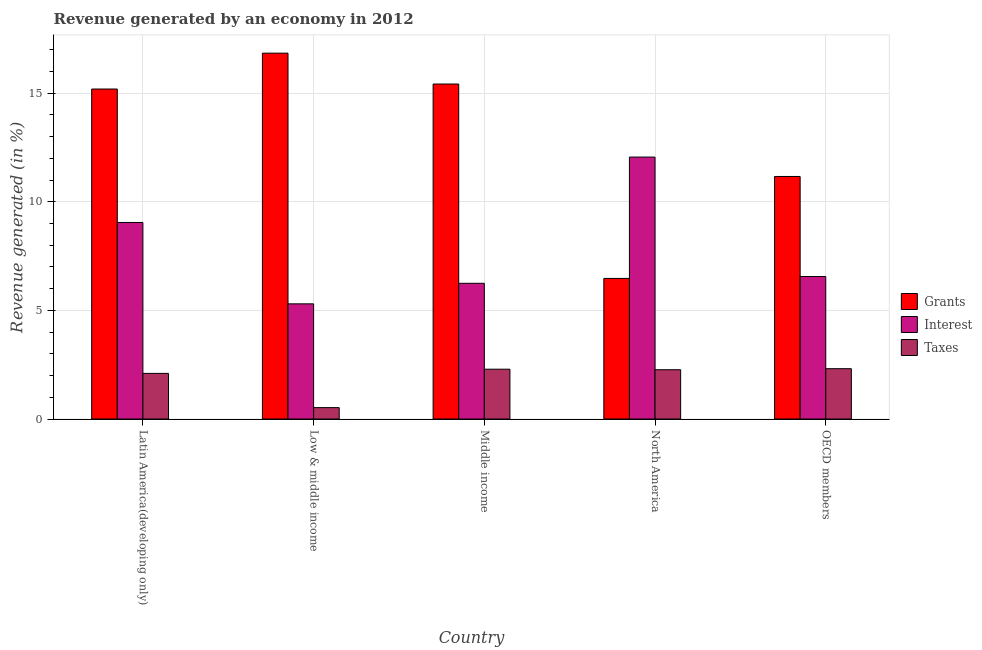How many groups of bars are there?
Give a very brief answer. 5. Are the number of bars per tick equal to the number of legend labels?
Offer a terse response. Yes. Are the number of bars on each tick of the X-axis equal?
Offer a terse response. Yes. In how many cases, is the number of bars for a given country not equal to the number of legend labels?
Your answer should be compact. 0. What is the percentage of revenue generated by taxes in Low & middle income?
Give a very brief answer. 0.52. Across all countries, what is the maximum percentage of revenue generated by grants?
Offer a very short reply. 16.84. Across all countries, what is the minimum percentage of revenue generated by interest?
Your response must be concise. 5.3. In which country was the percentage of revenue generated by taxes maximum?
Provide a short and direct response. OECD members. In which country was the percentage of revenue generated by taxes minimum?
Your response must be concise. Low & middle income. What is the total percentage of revenue generated by interest in the graph?
Provide a succinct answer. 39.21. What is the difference between the percentage of revenue generated by grants in North America and that in OECD members?
Give a very brief answer. -4.69. What is the difference between the percentage of revenue generated by grants in OECD members and the percentage of revenue generated by taxes in Middle income?
Ensure brevity in your answer.  8.87. What is the average percentage of revenue generated by taxes per country?
Offer a very short reply. 1.9. What is the difference between the percentage of revenue generated by interest and percentage of revenue generated by taxes in North America?
Your response must be concise. 9.79. What is the ratio of the percentage of revenue generated by taxes in Middle income to that in North America?
Provide a short and direct response. 1.01. Is the difference between the percentage of revenue generated by taxes in Middle income and North America greater than the difference between the percentage of revenue generated by grants in Middle income and North America?
Provide a succinct answer. No. What is the difference between the highest and the second highest percentage of revenue generated by interest?
Make the answer very short. 3.01. What is the difference between the highest and the lowest percentage of revenue generated by grants?
Your answer should be compact. 10.37. Is the sum of the percentage of revenue generated by taxes in Low & middle income and Middle income greater than the maximum percentage of revenue generated by interest across all countries?
Your response must be concise. No. What does the 2nd bar from the left in OECD members represents?
Make the answer very short. Interest. What does the 3rd bar from the right in Latin America(developing only) represents?
Give a very brief answer. Grants. How many bars are there?
Provide a succinct answer. 15. Are all the bars in the graph horizontal?
Offer a terse response. No. What is the difference between two consecutive major ticks on the Y-axis?
Your answer should be compact. 5. Are the values on the major ticks of Y-axis written in scientific E-notation?
Your answer should be compact. No. Where does the legend appear in the graph?
Offer a very short reply. Center right. What is the title of the graph?
Provide a succinct answer. Revenue generated by an economy in 2012. Does "Domestic economy" appear as one of the legend labels in the graph?
Your response must be concise. No. What is the label or title of the Y-axis?
Your answer should be very brief. Revenue generated (in %). What is the Revenue generated (in %) of Grants in Latin America(developing only)?
Provide a short and direct response. 15.19. What is the Revenue generated (in %) of Interest in Latin America(developing only)?
Offer a terse response. 9.05. What is the Revenue generated (in %) of Taxes in Latin America(developing only)?
Make the answer very short. 2.1. What is the Revenue generated (in %) in Grants in Low & middle income?
Your response must be concise. 16.84. What is the Revenue generated (in %) of Interest in Low & middle income?
Provide a succinct answer. 5.3. What is the Revenue generated (in %) of Taxes in Low & middle income?
Give a very brief answer. 0.52. What is the Revenue generated (in %) of Grants in Middle income?
Provide a short and direct response. 15.42. What is the Revenue generated (in %) of Interest in Middle income?
Provide a short and direct response. 6.25. What is the Revenue generated (in %) of Taxes in Middle income?
Ensure brevity in your answer.  2.29. What is the Revenue generated (in %) of Grants in North America?
Offer a terse response. 6.47. What is the Revenue generated (in %) in Interest in North America?
Ensure brevity in your answer.  12.06. What is the Revenue generated (in %) in Taxes in North America?
Offer a terse response. 2.27. What is the Revenue generated (in %) of Grants in OECD members?
Your answer should be very brief. 11.16. What is the Revenue generated (in %) in Interest in OECD members?
Your answer should be compact. 6.56. What is the Revenue generated (in %) of Taxes in OECD members?
Your answer should be very brief. 2.32. Across all countries, what is the maximum Revenue generated (in %) in Grants?
Provide a short and direct response. 16.84. Across all countries, what is the maximum Revenue generated (in %) in Interest?
Your answer should be compact. 12.06. Across all countries, what is the maximum Revenue generated (in %) of Taxes?
Keep it short and to the point. 2.32. Across all countries, what is the minimum Revenue generated (in %) of Grants?
Keep it short and to the point. 6.47. Across all countries, what is the minimum Revenue generated (in %) in Interest?
Make the answer very short. 5.3. Across all countries, what is the minimum Revenue generated (in %) of Taxes?
Offer a very short reply. 0.52. What is the total Revenue generated (in %) in Grants in the graph?
Keep it short and to the point. 65.08. What is the total Revenue generated (in %) of Interest in the graph?
Give a very brief answer. 39.21. What is the total Revenue generated (in %) in Taxes in the graph?
Your answer should be compact. 9.5. What is the difference between the Revenue generated (in %) of Grants in Latin America(developing only) and that in Low & middle income?
Your answer should be compact. -1.65. What is the difference between the Revenue generated (in %) in Interest in Latin America(developing only) and that in Low & middle income?
Ensure brevity in your answer.  3.75. What is the difference between the Revenue generated (in %) in Taxes in Latin America(developing only) and that in Low & middle income?
Provide a short and direct response. 1.58. What is the difference between the Revenue generated (in %) in Grants in Latin America(developing only) and that in Middle income?
Give a very brief answer. -0.23. What is the difference between the Revenue generated (in %) of Interest in Latin America(developing only) and that in Middle income?
Provide a short and direct response. 2.8. What is the difference between the Revenue generated (in %) in Taxes in Latin America(developing only) and that in Middle income?
Your answer should be very brief. -0.19. What is the difference between the Revenue generated (in %) of Grants in Latin America(developing only) and that in North America?
Make the answer very short. 8.72. What is the difference between the Revenue generated (in %) of Interest in Latin America(developing only) and that in North America?
Offer a very short reply. -3.01. What is the difference between the Revenue generated (in %) in Taxes in Latin America(developing only) and that in North America?
Provide a short and direct response. -0.17. What is the difference between the Revenue generated (in %) of Grants in Latin America(developing only) and that in OECD members?
Your answer should be compact. 4.03. What is the difference between the Revenue generated (in %) in Interest in Latin America(developing only) and that in OECD members?
Offer a very short reply. 2.49. What is the difference between the Revenue generated (in %) of Taxes in Latin America(developing only) and that in OECD members?
Make the answer very short. -0.22. What is the difference between the Revenue generated (in %) in Grants in Low & middle income and that in Middle income?
Make the answer very short. 1.42. What is the difference between the Revenue generated (in %) in Interest in Low & middle income and that in Middle income?
Provide a short and direct response. -0.95. What is the difference between the Revenue generated (in %) in Taxes in Low & middle income and that in Middle income?
Your answer should be compact. -1.77. What is the difference between the Revenue generated (in %) of Grants in Low & middle income and that in North America?
Offer a very short reply. 10.37. What is the difference between the Revenue generated (in %) of Interest in Low & middle income and that in North America?
Give a very brief answer. -6.76. What is the difference between the Revenue generated (in %) in Taxes in Low & middle income and that in North America?
Provide a short and direct response. -1.74. What is the difference between the Revenue generated (in %) in Grants in Low & middle income and that in OECD members?
Your answer should be compact. 5.68. What is the difference between the Revenue generated (in %) of Interest in Low & middle income and that in OECD members?
Your response must be concise. -1.26. What is the difference between the Revenue generated (in %) of Taxes in Low & middle income and that in OECD members?
Keep it short and to the point. -1.79. What is the difference between the Revenue generated (in %) in Grants in Middle income and that in North America?
Offer a terse response. 8.95. What is the difference between the Revenue generated (in %) in Interest in Middle income and that in North America?
Your response must be concise. -5.81. What is the difference between the Revenue generated (in %) of Taxes in Middle income and that in North America?
Your response must be concise. 0.02. What is the difference between the Revenue generated (in %) in Grants in Middle income and that in OECD members?
Your answer should be very brief. 4.26. What is the difference between the Revenue generated (in %) in Interest in Middle income and that in OECD members?
Provide a short and direct response. -0.31. What is the difference between the Revenue generated (in %) in Taxes in Middle income and that in OECD members?
Your response must be concise. -0.02. What is the difference between the Revenue generated (in %) of Grants in North America and that in OECD members?
Give a very brief answer. -4.69. What is the difference between the Revenue generated (in %) in Interest in North America and that in OECD members?
Your response must be concise. 5.5. What is the difference between the Revenue generated (in %) in Taxes in North America and that in OECD members?
Your answer should be compact. -0.05. What is the difference between the Revenue generated (in %) of Grants in Latin America(developing only) and the Revenue generated (in %) of Interest in Low & middle income?
Provide a short and direct response. 9.89. What is the difference between the Revenue generated (in %) of Grants in Latin America(developing only) and the Revenue generated (in %) of Taxes in Low & middle income?
Provide a succinct answer. 14.66. What is the difference between the Revenue generated (in %) in Interest in Latin America(developing only) and the Revenue generated (in %) in Taxes in Low & middle income?
Your response must be concise. 8.52. What is the difference between the Revenue generated (in %) of Grants in Latin America(developing only) and the Revenue generated (in %) of Interest in Middle income?
Make the answer very short. 8.94. What is the difference between the Revenue generated (in %) in Grants in Latin America(developing only) and the Revenue generated (in %) in Taxes in Middle income?
Provide a short and direct response. 12.9. What is the difference between the Revenue generated (in %) in Interest in Latin America(developing only) and the Revenue generated (in %) in Taxes in Middle income?
Give a very brief answer. 6.75. What is the difference between the Revenue generated (in %) of Grants in Latin America(developing only) and the Revenue generated (in %) of Interest in North America?
Offer a very short reply. 3.13. What is the difference between the Revenue generated (in %) in Grants in Latin America(developing only) and the Revenue generated (in %) in Taxes in North America?
Your answer should be compact. 12.92. What is the difference between the Revenue generated (in %) in Interest in Latin America(developing only) and the Revenue generated (in %) in Taxes in North America?
Provide a succinct answer. 6.78. What is the difference between the Revenue generated (in %) of Grants in Latin America(developing only) and the Revenue generated (in %) of Interest in OECD members?
Offer a terse response. 8.63. What is the difference between the Revenue generated (in %) in Grants in Latin America(developing only) and the Revenue generated (in %) in Taxes in OECD members?
Offer a very short reply. 12.87. What is the difference between the Revenue generated (in %) of Interest in Latin America(developing only) and the Revenue generated (in %) of Taxes in OECD members?
Keep it short and to the point. 6.73. What is the difference between the Revenue generated (in %) of Grants in Low & middle income and the Revenue generated (in %) of Interest in Middle income?
Provide a succinct answer. 10.59. What is the difference between the Revenue generated (in %) in Grants in Low & middle income and the Revenue generated (in %) in Taxes in Middle income?
Give a very brief answer. 14.55. What is the difference between the Revenue generated (in %) in Interest in Low & middle income and the Revenue generated (in %) in Taxes in Middle income?
Your response must be concise. 3.01. What is the difference between the Revenue generated (in %) in Grants in Low & middle income and the Revenue generated (in %) in Interest in North America?
Offer a terse response. 4.78. What is the difference between the Revenue generated (in %) of Grants in Low & middle income and the Revenue generated (in %) of Taxes in North America?
Offer a terse response. 14.57. What is the difference between the Revenue generated (in %) of Interest in Low & middle income and the Revenue generated (in %) of Taxes in North America?
Give a very brief answer. 3.03. What is the difference between the Revenue generated (in %) of Grants in Low & middle income and the Revenue generated (in %) of Interest in OECD members?
Provide a short and direct response. 10.28. What is the difference between the Revenue generated (in %) of Grants in Low & middle income and the Revenue generated (in %) of Taxes in OECD members?
Your answer should be very brief. 14.52. What is the difference between the Revenue generated (in %) of Interest in Low & middle income and the Revenue generated (in %) of Taxes in OECD members?
Your answer should be very brief. 2.98. What is the difference between the Revenue generated (in %) in Grants in Middle income and the Revenue generated (in %) in Interest in North America?
Provide a short and direct response. 3.36. What is the difference between the Revenue generated (in %) of Grants in Middle income and the Revenue generated (in %) of Taxes in North America?
Your answer should be compact. 13.15. What is the difference between the Revenue generated (in %) in Interest in Middle income and the Revenue generated (in %) in Taxes in North America?
Give a very brief answer. 3.98. What is the difference between the Revenue generated (in %) in Grants in Middle income and the Revenue generated (in %) in Interest in OECD members?
Make the answer very short. 8.86. What is the difference between the Revenue generated (in %) in Grants in Middle income and the Revenue generated (in %) in Taxes in OECD members?
Give a very brief answer. 13.1. What is the difference between the Revenue generated (in %) of Interest in Middle income and the Revenue generated (in %) of Taxes in OECD members?
Your answer should be very brief. 3.93. What is the difference between the Revenue generated (in %) in Grants in North America and the Revenue generated (in %) in Interest in OECD members?
Give a very brief answer. -0.09. What is the difference between the Revenue generated (in %) in Grants in North America and the Revenue generated (in %) in Taxes in OECD members?
Make the answer very short. 4.16. What is the difference between the Revenue generated (in %) in Interest in North America and the Revenue generated (in %) in Taxes in OECD members?
Make the answer very short. 9.74. What is the average Revenue generated (in %) of Grants per country?
Offer a very short reply. 13.02. What is the average Revenue generated (in %) of Interest per country?
Provide a short and direct response. 7.84. What is the average Revenue generated (in %) of Taxes per country?
Keep it short and to the point. 1.9. What is the difference between the Revenue generated (in %) of Grants and Revenue generated (in %) of Interest in Latin America(developing only)?
Give a very brief answer. 6.14. What is the difference between the Revenue generated (in %) in Grants and Revenue generated (in %) in Taxes in Latin America(developing only)?
Keep it short and to the point. 13.09. What is the difference between the Revenue generated (in %) of Interest and Revenue generated (in %) of Taxes in Latin America(developing only)?
Make the answer very short. 6.95. What is the difference between the Revenue generated (in %) in Grants and Revenue generated (in %) in Interest in Low & middle income?
Your answer should be compact. 11.54. What is the difference between the Revenue generated (in %) of Grants and Revenue generated (in %) of Taxes in Low & middle income?
Make the answer very short. 16.31. What is the difference between the Revenue generated (in %) in Interest and Revenue generated (in %) in Taxes in Low & middle income?
Provide a short and direct response. 4.78. What is the difference between the Revenue generated (in %) of Grants and Revenue generated (in %) of Interest in Middle income?
Your response must be concise. 9.17. What is the difference between the Revenue generated (in %) in Grants and Revenue generated (in %) in Taxes in Middle income?
Make the answer very short. 13.13. What is the difference between the Revenue generated (in %) in Interest and Revenue generated (in %) in Taxes in Middle income?
Ensure brevity in your answer.  3.95. What is the difference between the Revenue generated (in %) of Grants and Revenue generated (in %) of Interest in North America?
Provide a succinct answer. -5.58. What is the difference between the Revenue generated (in %) of Grants and Revenue generated (in %) of Taxes in North America?
Your response must be concise. 4.2. What is the difference between the Revenue generated (in %) in Interest and Revenue generated (in %) in Taxes in North America?
Your response must be concise. 9.79. What is the difference between the Revenue generated (in %) in Grants and Revenue generated (in %) in Interest in OECD members?
Provide a succinct answer. 4.61. What is the difference between the Revenue generated (in %) of Grants and Revenue generated (in %) of Taxes in OECD members?
Keep it short and to the point. 8.85. What is the difference between the Revenue generated (in %) in Interest and Revenue generated (in %) in Taxes in OECD members?
Provide a succinct answer. 4.24. What is the ratio of the Revenue generated (in %) in Grants in Latin America(developing only) to that in Low & middle income?
Offer a terse response. 0.9. What is the ratio of the Revenue generated (in %) in Interest in Latin America(developing only) to that in Low & middle income?
Provide a short and direct response. 1.71. What is the ratio of the Revenue generated (in %) of Taxes in Latin America(developing only) to that in Low & middle income?
Give a very brief answer. 4. What is the ratio of the Revenue generated (in %) of Grants in Latin America(developing only) to that in Middle income?
Give a very brief answer. 0.99. What is the ratio of the Revenue generated (in %) of Interest in Latin America(developing only) to that in Middle income?
Ensure brevity in your answer.  1.45. What is the ratio of the Revenue generated (in %) of Taxes in Latin America(developing only) to that in Middle income?
Provide a succinct answer. 0.92. What is the ratio of the Revenue generated (in %) of Grants in Latin America(developing only) to that in North America?
Give a very brief answer. 2.35. What is the ratio of the Revenue generated (in %) of Interest in Latin America(developing only) to that in North America?
Your response must be concise. 0.75. What is the ratio of the Revenue generated (in %) in Taxes in Latin America(developing only) to that in North America?
Make the answer very short. 0.93. What is the ratio of the Revenue generated (in %) in Grants in Latin America(developing only) to that in OECD members?
Your response must be concise. 1.36. What is the ratio of the Revenue generated (in %) of Interest in Latin America(developing only) to that in OECD members?
Your answer should be very brief. 1.38. What is the ratio of the Revenue generated (in %) of Taxes in Latin America(developing only) to that in OECD members?
Provide a succinct answer. 0.91. What is the ratio of the Revenue generated (in %) in Grants in Low & middle income to that in Middle income?
Your response must be concise. 1.09. What is the ratio of the Revenue generated (in %) of Interest in Low & middle income to that in Middle income?
Your response must be concise. 0.85. What is the ratio of the Revenue generated (in %) of Taxes in Low & middle income to that in Middle income?
Provide a short and direct response. 0.23. What is the ratio of the Revenue generated (in %) in Grants in Low & middle income to that in North America?
Your response must be concise. 2.6. What is the ratio of the Revenue generated (in %) of Interest in Low & middle income to that in North America?
Your response must be concise. 0.44. What is the ratio of the Revenue generated (in %) in Taxes in Low & middle income to that in North America?
Your answer should be compact. 0.23. What is the ratio of the Revenue generated (in %) in Grants in Low & middle income to that in OECD members?
Offer a terse response. 1.51. What is the ratio of the Revenue generated (in %) in Interest in Low & middle income to that in OECD members?
Offer a terse response. 0.81. What is the ratio of the Revenue generated (in %) of Taxes in Low & middle income to that in OECD members?
Offer a very short reply. 0.23. What is the ratio of the Revenue generated (in %) in Grants in Middle income to that in North America?
Your answer should be very brief. 2.38. What is the ratio of the Revenue generated (in %) in Interest in Middle income to that in North America?
Your response must be concise. 0.52. What is the ratio of the Revenue generated (in %) of Taxes in Middle income to that in North America?
Your answer should be very brief. 1.01. What is the ratio of the Revenue generated (in %) in Grants in Middle income to that in OECD members?
Give a very brief answer. 1.38. What is the ratio of the Revenue generated (in %) of Interest in Middle income to that in OECD members?
Your response must be concise. 0.95. What is the ratio of the Revenue generated (in %) of Taxes in Middle income to that in OECD members?
Your answer should be very brief. 0.99. What is the ratio of the Revenue generated (in %) in Grants in North America to that in OECD members?
Provide a succinct answer. 0.58. What is the ratio of the Revenue generated (in %) of Interest in North America to that in OECD members?
Your answer should be very brief. 1.84. What is the ratio of the Revenue generated (in %) of Taxes in North America to that in OECD members?
Provide a short and direct response. 0.98. What is the difference between the highest and the second highest Revenue generated (in %) in Grants?
Your response must be concise. 1.42. What is the difference between the highest and the second highest Revenue generated (in %) of Interest?
Make the answer very short. 3.01. What is the difference between the highest and the second highest Revenue generated (in %) of Taxes?
Ensure brevity in your answer.  0.02. What is the difference between the highest and the lowest Revenue generated (in %) of Grants?
Keep it short and to the point. 10.37. What is the difference between the highest and the lowest Revenue generated (in %) in Interest?
Offer a terse response. 6.76. What is the difference between the highest and the lowest Revenue generated (in %) of Taxes?
Provide a succinct answer. 1.79. 